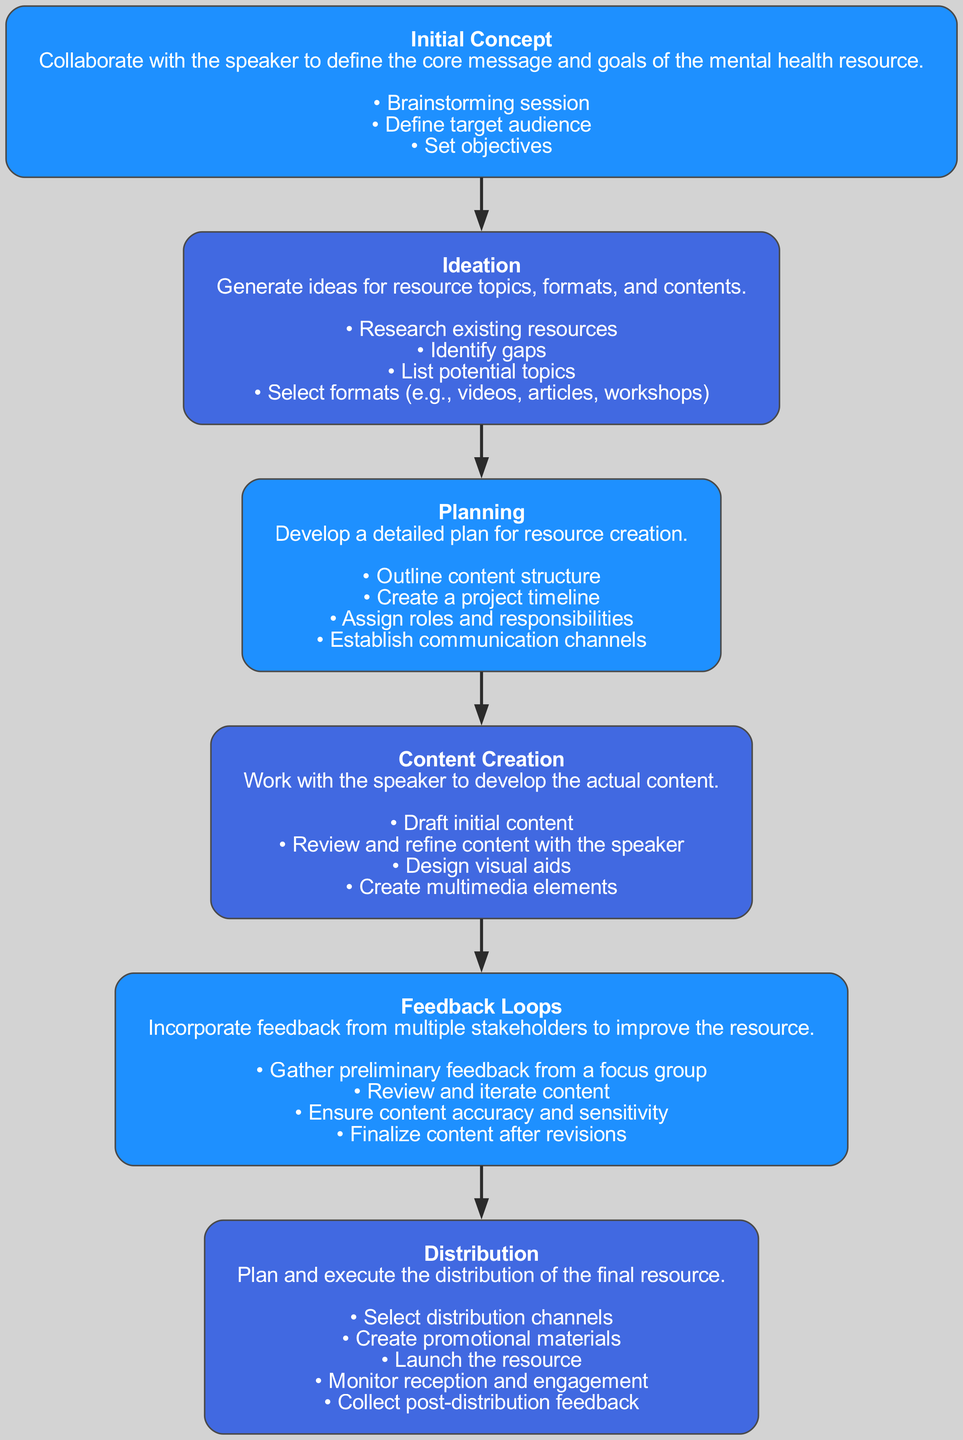What is the first stage in the diagram? The diagram lists the stages sequentially. The first stage is indicated as "Initial Concept".
Answer: Initial Concept How many tasks are associated with the "Content Creation" stage? The "Content Creation" stage contains four tasks: "Draft initial content", "Review and refine content with the speaker", "Design visual aids", and "Create multimedia elements". Counting those gives a total of four tasks.
Answer: 4 What is the last stage in the diagram? The last stage is called "Distribution", which can be identified as it is the final node in the sequence.
Answer: Distribution Which stage involves "Gather preliminary feedback from a focus group"? This identified task relates to the "Feedback Loops" stage, as it specifically mentions gathering feedback, which is a part of enhancing and finalizing content.
Answer: Feedback Loops Identify the alternate color used for nodes in even stages. According to the description of node styles, the alternate color for even stages is "#1E90FF".
Answer: #1E90FF What is the primary goal of the "Planning" stage? The goal of the "Planning" stage focuses on developing a detailed plan for resource creation, which can be inferred from the description provided in the node.
Answer: Develop a detailed plan How many stages are outlined in the diagram? By counting the stages listed in the data, there are a total of six stages: "Initial Concept", "Ideation", "Planning", "Content Creation", "Feedback Loops", and "Distribution".
Answer: 6 What flows into the 'Content Creation' stage from the previous stage? The "Content Creation" stage is directly preceded by the "Planning" stage, indicating that the outputs or plans from that stage flow into it.
Answer: Planning Which task is related to ensuring the content's accuracy? The task focused on content accuracy is found under "Feedback Loops" and specifically states, "Ensure content accuracy and sensitivity", indicating its importance in this stage.
Answer: Ensure content accuracy and sensitivity 